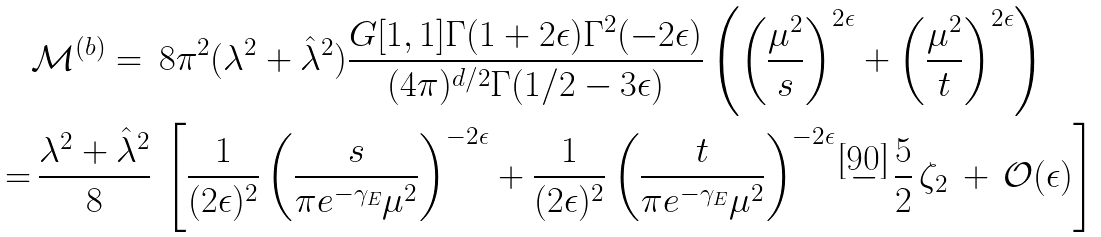Convert formula to latex. <formula><loc_0><loc_0><loc_500><loc_500>& \mathcal { M } ^ { ( b ) } = \, 8 \pi ^ { 2 } ( \lambda ^ { 2 } + \hat { \lambda } ^ { 2 } ) \frac { G [ 1 , 1 ] \Gamma ( 1 + 2 \epsilon ) \Gamma ^ { 2 } ( - 2 \epsilon ) } { ( 4 \pi ) ^ { d / 2 } \Gamma ( 1 / 2 - 3 \epsilon ) } \left ( \left ( \frac { \mu ^ { 2 } } { s } \right ) ^ { 2 \epsilon } + \left ( \frac { \mu ^ { 2 } } { t } \right ) ^ { 2 \epsilon } \right ) \\ = & \, \frac { \lambda ^ { 2 } + \hat { \lambda } ^ { 2 } } { 8 } \, \left [ \frac { 1 } { ( 2 \epsilon ) ^ { 2 } } \left ( \frac { s } { \pi e ^ { - \gamma _ { E } } \mu ^ { 2 } } \right ) ^ { - 2 \epsilon } + \frac { 1 } { ( 2 \epsilon ) ^ { 2 } } \left ( \frac { t } { \pi e ^ { - \gamma _ { E } } \mu ^ { 2 } } \right ) ^ { - 2 \epsilon } \, - \, \frac { 5 } { 2 } \, \zeta _ { 2 } \, + \, \mathcal { O } ( \epsilon ) \right ]</formula> 